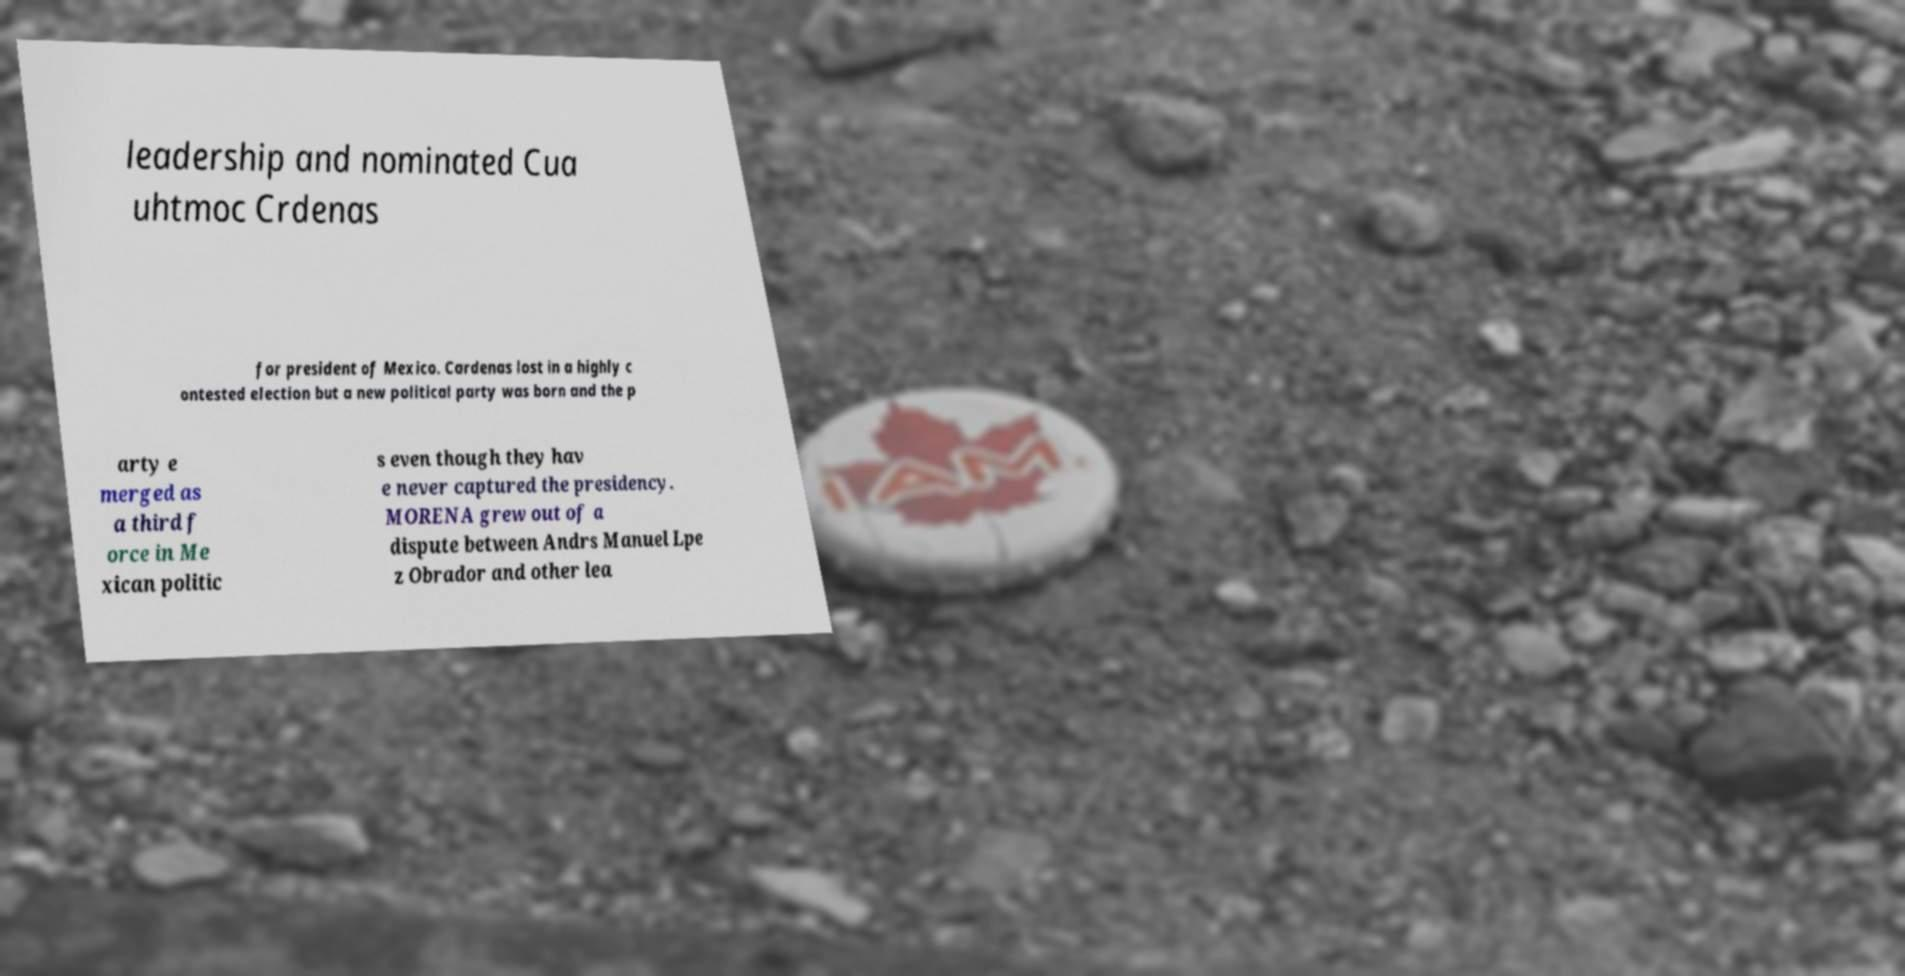There's text embedded in this image that I need extracted. Can you transcribe it verbatim? leadership and nominated Cua uhtmoc Crdenas for president of Mexico. Cardenas lost in a highly c ontested election but a new political party was born and the p arty e merged as a third f orce in Me xican politic s even though they hav e never captured the presidency. MORENA grew out of a dispute between Andrs Manuel Lpe z Obrador and other lea 